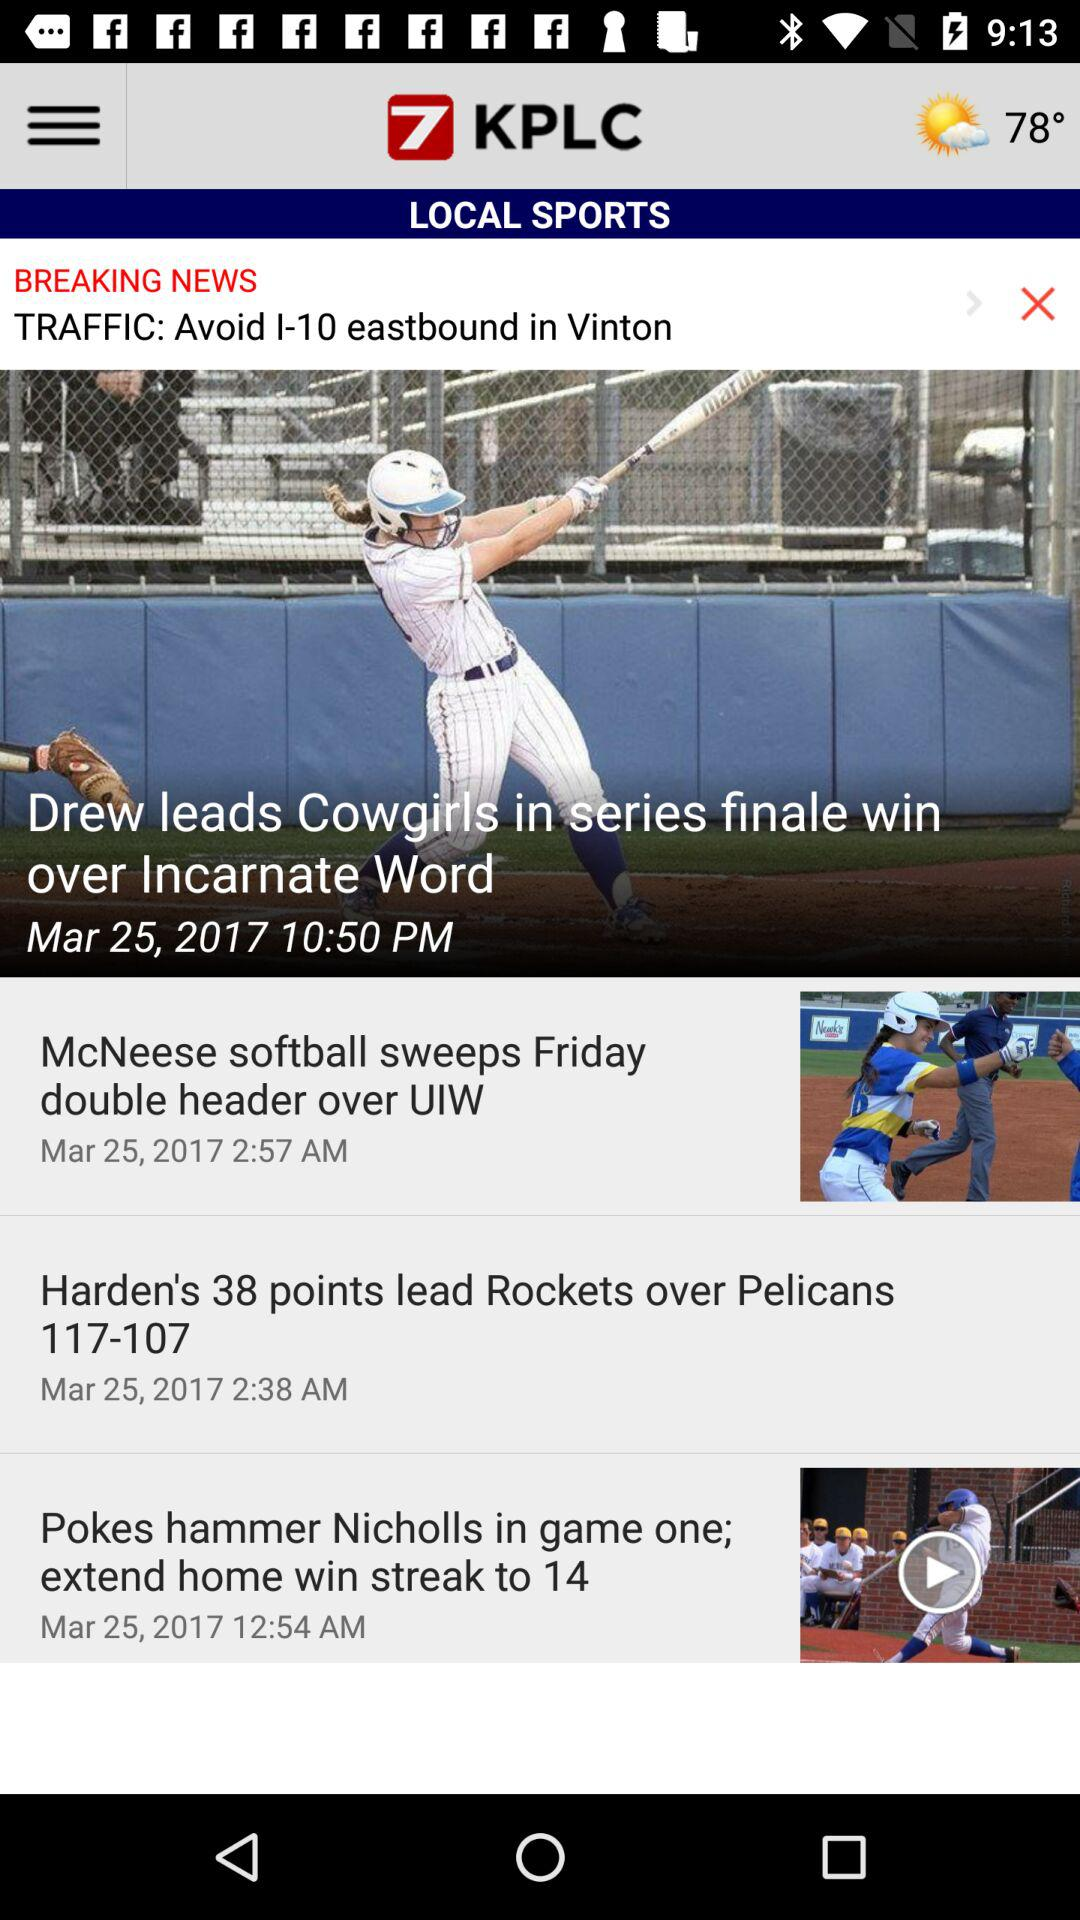How many more stories are there about sports than breaking news?
Answer the question using a single word or phrase. 2 